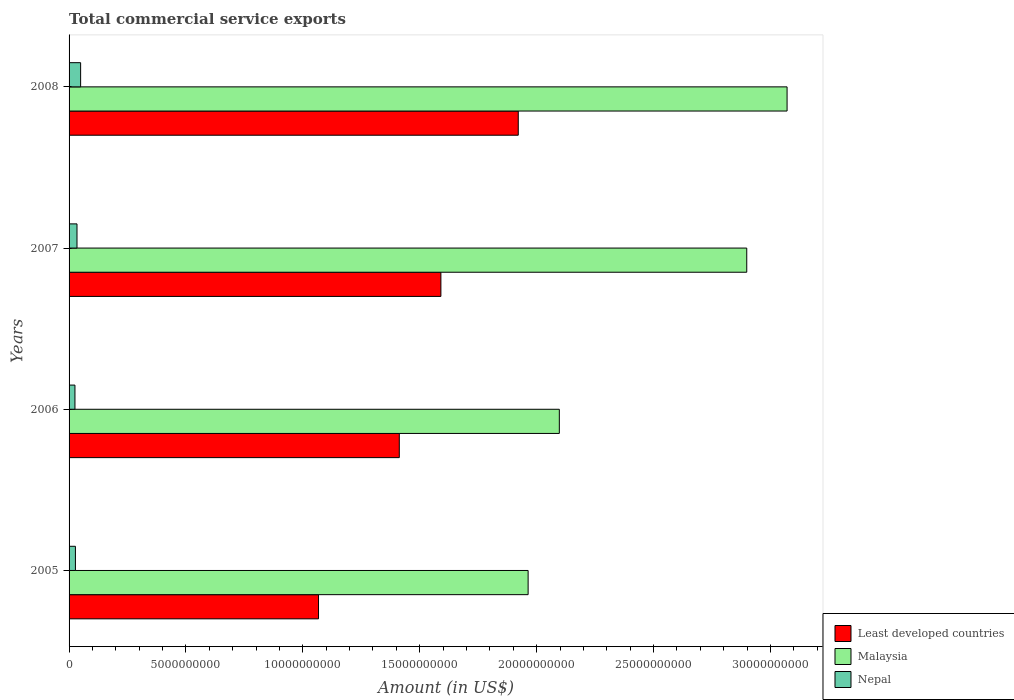How many groups of bars are there?
Keep it short and to the point. 4. Are the number of bars per tick equal to the number of legend labels?
Offer a terse response. Yes. Are the number of bars on each tick of the Y-axis equal?
Ensure brevity in your answer.  Yes. In how many cases, is the number of bars for a given year not equal to the number of legend labels?
Your response must be concise. 0. What is the total commercial service exports in Nepal in 2006?
Give a very brief answer. 2.52e+08. Across all years, what is the maximum total commercial service exports in Malaysia?
Your answer should be compact. 3.07e+1. Across all years, what is the minimum total commercial service exports in Malaysia?
Your response must be concise. 1.96e+1. In which year was the total commercial service exports in Nepal maximum?
Offer a terse response. 2008. What is the total total commercial service exports in Malaysia in the graph?
Offer a terse response. 1.00e+11. What is the difference between the total commercial service exports in Least developed countries in 2005 and that in 2006?
Offer a terse response. -3.46e+09. What is the difference between the total commercial service exports in Nepal in 2006 and the total commercial service exports in Malaysia in 2008?
Provide a succinct answer. -3.05e+1. What is the average total commercial service exports in Nepal per year?
Make the answer very short. 3.39e+08. In the year 2008, what is the difference between the total commercial service exports in Nepal and total commercial service exports in Least developed countries?
Offer a very short reply. -1.87e+1. What is the ratio of the total commercial service exports in Malaysia in 2006 to that in 2007?
Provide a succinct answer. 0.72. Is the total commercial service exports in Least developed countries in 2005 less than that in 2008?
Offer a very short reply. Yes. Is the difference between the total commercial service exports in Nepal in 2006 and 2008 greater than the difference between the total commercial service exports in Least developed countries in 2006 and 2008?
Provide a short and direct response. Yes. What is the difference between the highest and the second highest total commercial service exports in Nepal?
Provide a succinct answer. 1.55e+08. What is the difference between the highest and the lowest total commercial service exports in Malaysia?
Offer a terse response. 1.11e+1. Is the sum of the total commercial service exports in Least developed countries in 2006 and 2007 greater than the maximum total commercial service exports in Malaysia across all years?
Your answer should be very brief. No. What does the 1st bar from the top in 2007 represents?
Keep it short and to the point. Nepal. What does the 2nd bar from the bottom in 2005 represents?
Offer a very short reply. Malaysia. Are all the bars in the graph horizontal?
Your answer should be very brief. Yes. What is the difference between two consecutive major ticks on the X-axis?
Ensure brevity in your answer.  5.00e+09. How many legend labels are there?
Your answer should be compact. 3. What is the title of the graph?
Keep it short and to the point. Total commercial service exports. Does "Arab World" appear as one of the legend labels in the graph?
Keep it short and to the point. No. What is the label or title of the Y-axis?
Give a very brief answer. Years. What is the Amount (in US$) of Least developed countries in 2005?
Offer a terse response. 1.07e+1. What is the Amount (in US$) in Malaysia in 2005?
Your response must be concise. 1.96e+1. What is the Amount (in US$) of Nepal in 2005?
Make the answer very short. 2.71e+08. What is the Amount (in US$) of Least developed countries in 2006?
Provide a short and direct response. 1.41e+1. What is the Amount (in US$) in Malaysia in 2006?
Your answer should be compact. 2.10e+1. What is the Amount (in US$) in Nepal in 2006?
Give a very brief answer. 2.52e+08. What is the Amount (in US$) of Least developed countries in 2007?
Offer a terse response. 1.59e+1. What is the Amount (in US$) of Malaysia in 2007?
Provide a short and direct response. 2.90e+1. What is the Amount (in US$) in Nepal in 2007?
Provide a succinct answer. 3.40e+08. What is the Amount (in US$) in Least developed countries in 2008?
Ensure brevity in your answer.  1.92e+1. What is the Amount (in US$) in Malaysia in 2008?
Your answer should be very brief. 3.07e+1. What is the Amount (in US$) of Nepal in 2008?
Your answer should be compact. 4.94e+08. Across all years, what is the maximum Amount (in US$) of Least developed countries?
Your answer should be compact. 1.92e+1. Across all years, what is the maximum Amount (in US$) in Malaysia?
Your answer should be very brief. 3.07e+1. Across all years, what is the maximum Amount (in US$) of Nepal?
Offer a very short reply. 4.94e+08. Across all years, what is the minimum Amount (in US$) in Least developed countries?
Keep it short and to the point. 1.07e+1. Across all years, what is the minimum Amount (in US$) in Malaysia?
Provide a short and direct response. 1.96e+1. Across all years, what is the minimum Amount (in US$) in Nepal?
Offer a terse response. 2.52e+08. What is the total Amount (in US$) of Least developed countries in the graph?
Offer a very short reply. 5.99e+1. What is the total Amount (in US$) of Malaysia in the graph?
Give a very brief answer. 1.00e+11. What is the total Amount (in US$) of Nepal in the graph?
Offer a terse response. 1.36e+09. What is the difference between the Amount (in US$) of Least developed countries in 2005 and that in 2006?
Give a very brief answer. -3.46e+09. What is the difference between the Amount (in US$) of Malaysia in 2005 and that in 2006?
Give a very brief answer. -1.33e+09. What is the difference between the Amount (in US$) in Nepal in 2005 and that in 2006?
Your answer should be compact. 1.97e+07. What is the difference between the Amount (in US$) in Least developed countries in 2005 and that in 2007?
Your answer should be very brief. -5.23e+09. What is the difference between the Amount (in US$) in Malaysia in 2005 and that in 2007?
Your answer should be compact. -9.35e+09. What is the difference between the Amount (in US$) in Nepal in 2005 and that in 2007?
Provide a succinct answer. -6.81e+07. What is the difference between the Amount (in US$) in Least developed countries in 2005 and that in 2008?
Provide a short and direct response. -8.54e+09. What is the difference between the Amount (in US$) of Malaysia in 2005 and that in 2008?
Make the answer very short. -1.11e+1. What is the difference between the Amount (in US$) of Nepal in 2005 and that in 2008?
Provide a short and direct response. -2.23e+08. What is the difference between the Amount (in US$) in Least developed countries in 2006 and that in 2007?
Keep it short and to the point. -1.78e+09. What is the difference between the Amount (in US$) in Malaysia in 2006 and that in 2007?
Your response must be concise. -8.02e+09. What is the difference between the Amount (in US$) in Nepal in 2006 and that in 2007?
Your answer should be compact. -8.78e+07. What is the difference between the Amount (in US$) of Least developed countries in 2006 and that in 2008?
Offer a terse response. -5.09e+09. What is the difference between the Amount (in US$) of Malaysia in 2006 and that in 2008?
Provide a succinct answer. -9.74e+09. What is the difference between the Amount (in US$) in Nepal in 2006 and that in 2008?
Ensure brevity in your answer.  -2.43e+08. What is the difference between the Amount (in US$) in Least developed countries in 2007 and that in 2008?
Offer a very short reply. -3.31e+09. What is the difference between the Amount (in US$) of Malaysia in 2007 and that in 2008?
Provide a succinct answer. -1.73e+09. What is the difference between the Amount (in US$) of Nepal in 2007 and that in 2008?
Your answer should be compact. -1.55e+08. What is the difference between the Amount (in US$) of Least developed countries in 2005 and the Amount (in US$) of Malaysia in 2006?
Make the answer very short. -1.03e+1. What is the difference between the Amount (in US$) of Least developed countries in 2005 and the Amount (in US$) of Nepal in 2006?
Your answer should be very brief. 1.04e+1. What is the difference between the Amount (in US$) of Malaysia in 2005 and the Amount (in US$) of Nepal in 2006?
Your answer should be compact. 1.94e+1. What is the difference between the Amount (in US$) in Least developed countries in 2005 and the Amount (in US$) in Malaysia in 2007?
Your answer should be compact. -1.83e+1. What is the difference between the Amount (in US$) of Least developed countries in 2005 and the Amount (in US$) of Nepal in 2007?
Your answer should be compact. 1.03e+1. What is the difference between the Amount (in US$) of Malaysia in 2005 and the Amount (in US$) of Nepal in 2007?
Provide a short and direct response. 1.93e+1. What is the difference between the Amount (in US$) of Least developed countries in 2005 and the Amount (in US$) of Malaysia in 2008?
Provide a short and direct response. -2.00e+1. What is the difference between the Amount (in US$) in Least developed countries in 2005 and the Amount (in US$) in Nepal in 2008?
Your answer should be compact. 1.02e+1. What is the difference between the Amount (in US$) of Malaysia in 2005 and the Amount (in US$) of Nepal in 2008?
Give a very brief answer. 1.91e+1. What is the difference between the Amount (in US$) in Least developed countries in 2006 and the Amount (in US$) in Malaysia in 2007?
Your answer should be compact. -1.49e+1. What is the difference between the Amount (in US$) in Least developed countries in 2006 and the Amount (in US$) in Nepal in 2007?
Give a very brief answer. 1.38e+1. What is the difference between the Amount (in US$) in Malaysia in 2006 and the Amount (in US$) in Nepal in 2007?
Your answer should be very brief. 2.06e+1. What is the difference between the Amount (in US$) of Least developed countries in 2006 and the Amount (in US$) of Malaysia in 2008?
Your answer should be very brief. -1.66e+1. What is the difference between the Amount (in US$) in Least developed countries in 2006 and the Amount (in US$) in Nepal in 2008?
Provide a succinct answer. 1.36e+1. What is the difference between the Amount (in US$) of Malaysia in 2006 and the Amount (in US$) of Nepal in 2008?
Your answer should be compact. 2.05e+1. What is the difference between the Amount (in US$) in Least developed countries in 2007 and the Amount (in US$) in Malaysia in 2008?
Provide a succinct answer. -1.48e+1. What is the difference between the Amount (in US$) of Least developed countries in 2007 and the Amount (in US$) of Nepal in 2008?
Ensure brevity in your answer.  1.54e+1. What is the difference between the Amount (in US$) of Malaysia in 2007 and the Amount (in US$) of Nepal in 2008?
Provide a short and direct response. 2.85e+1. What is the average Amount (in US$) in Least developed countries per year?
Your answer should be very brief. 1.50e+1. What is the average Amount (in US$) in Malaysia per year?
Your response must be concise. 2.51e+1. What is the average Amount (in US$) of Nepal per year?
Offer a terse response. 3.39e+08. In the year 2005, what is the difference between the Amount (in US$) of Least developed countries and Amount (in US$) of Malaysia?
Make the answer very short. -8.97e+09. In the year 2005, what is the difference between the Amount (in US$) of Least developed countries and Amount (in US$) of Nepal?
Keep it short and to the point. 1.04e+1. In the year 2005, what is the difference between the Amount (in US$) of Malaysia and Amount (in US$) of Nepal?
Provide a succinct answer. 1.94e+1. In the year 2006, what is the difference between the Amount (in US$) of Least developed countries and Amount (in US$) of Malaysia?
Ensure brevity in your answer.  -6.85e+09. In the year 2006, what is the difference between the Amount (in US$) in Least developed countries and Amount (in US$) in Nepal?
Make the answer very short. 1.39e+1. In the year 2006, what is the difference between the Amount (in US$) of Malaysia and Amount (in US$) of Nepal?
Provide a succinct answer. 2.07e+1. In the year 2007, what is the difference between the Amount (in US$) in Least developed countries and Amount (in US$) in Malaysia?
Offer a very short reply. -1.31e+1. In the year 2007, what is the difference between the Amount (in US$) of Least developed countries and Amount (in US$) of Nepal?
Offer a very short reply. 1.56e+1. In the year 2007, what is the difference between the Amount (in US$) in Malaysia and Amount (in US$) in Nepal?
Your response must be concise. 2.86e+1. In the year 2008, what is the difference between the Amount (in US$) of Least developed countries and Amount (in US$) of Malaysia?
Offer a very short reply. -1.15e+1. In the year 2008, what is the difference between the Amount (in US$) in Least developed countries and Amount (in US$) in Nepal?
Provide a short and direct response. 1.87e+1. In the year 2008, what is the difference between the Amount (in US$) of Malaysia and Amount (in US$) of Nepal?
Your answer should be very brief. 3.02e+1. What is the ratio of the Amount (in US$) of Least developed countries in 2005 to that in 2006?
Provide a short and direct response. 0.76. What is the ratio of the Amount (in US$) of Malaysia in 2005 to that in 2006?
Make the answer very short. 0.94. What is the ratio of the Amount (in US$) of Nepal in 2005 to that in 2006?
Keep it short and to the point. 1.08. What is the ratio of the Amount (in US$) in Least developed countries in 2005 to that in 2007?
Offer a terse response. 0.67. What is the ratio of the Amount (in US$) of Malaysia in 2005 to that in 2007?
Make the answer very short. 0.68. What is the ratio of the Amount (in US$) in Nepal in 2005 to that in 2007?
Make the answer very short. 0.8. What is the ratio of the Amount (in US$) of Least developed countries in 2005 to that in 2008?
Provide a succinct answer. 0.56. What is the ratio of the Amount (in US$) in Malaysia in 2005 to that in 2008?
Give a very brief answer. 0.64. What is the ratio of the Amount (in US$) of Nepal in 2005 to that in 2008?
Ensure brevity in your answer.  0.55. What is the ratio of the Amount (in US$) in Least developed countries in 2006 to that in 2007?
Your answer should be compact. 0.89. What is the ratio of the Amount (in US$) of Malaysia in 2006 to that in 2007?
Make the answer very short. 0.72. What is the ratio of the Amount (in US$) in Nepal in 2006 to that in 2007?
Make the answer very short. 0.74. What is the ratio of the Amount (in US$) of Least developed countries in 2006 to that in 2008?
Ensure brevity in your answer.  0.74. What is the ratio of the Amount (in US$) of Malaysia in 2006 to that in 2008?
Offer a terse response. 0.68. What is the ratio of the Amount (in US$) in Nepal in 2006 to that in 2008?
Keep it short and to the point. 0.51. What is the ratio of the Amount (in US$) in Least developed countries in 2007 to that in 2008?
Your answer should be very brief. 0.83. What is the ratio of the Amount (in US$) of Malaysia in 2007 to that in 2008?
Ensure brevity in your answer.  0.94. What is the ratio of the Amount (in US$) of Nepal in 2007 to that in 2008?
Your answer should be compact. 0.69. What is the difference between the highest and the second highest Amount (in US$) of Least developed countries?
Provide a succinct answer. 3.31e+09. What is the difference between the highest and the second highest Amount (in US$) in Malaysia?
Provide a succinct answer. 1.73e+09. What is the difference between the highest and the second highest Amount (in US$) of Nepal?
Your response must be concise. 1.55e+08. What is the difference between the highest and the lowest Amount (in US$) of Least developed countries?
Make the answer very short. 8.54e+09. What is the difference between the highest and the lowest Amount (in US$) of Malaysia?
Keep it short and to the point. 1.11e+1. What is the difference between the highest and the lowest Amount (in US$) in Nepal?
Provide a succinct answer. 2.43e+08. 